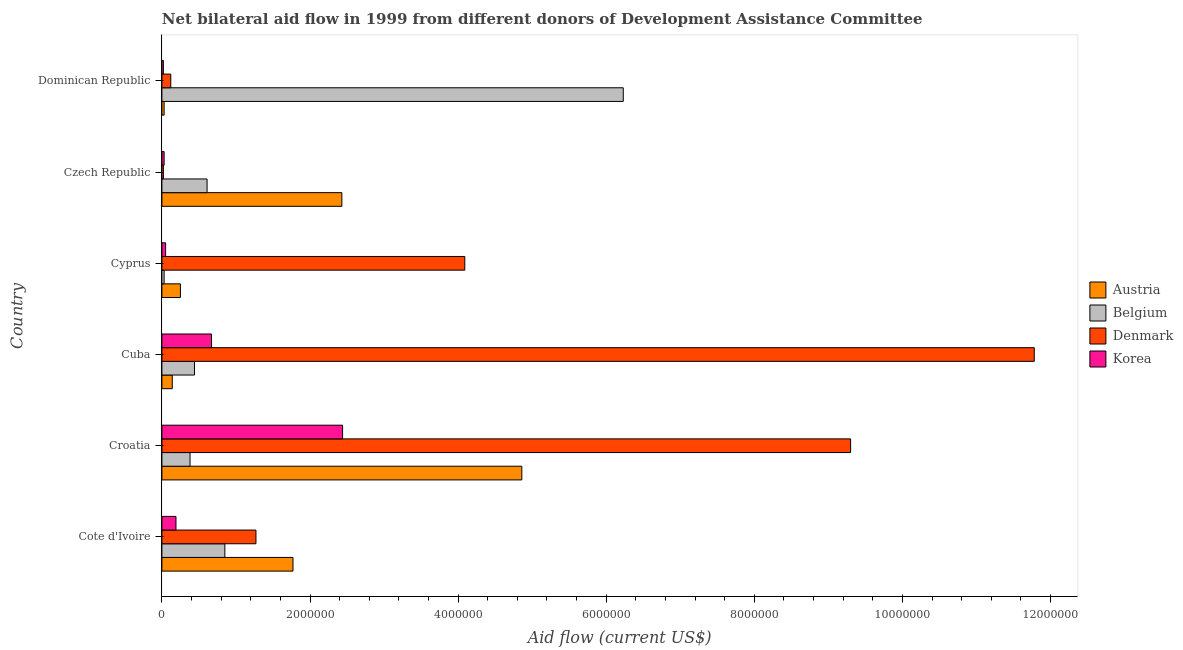Are the number of bars on each tick of the Y-axis equal?
Provide a succinct answer. Yes. How many bars are there on the 3rd tick from the bottom?
Your answer should be very brief. 4. What is the label of the 4th group of bars from the top?
Your answer should be compact. Cuba. What is the amount of aid given by korea in Dominican Republic?
Make the answer very short. 2.00e+04. Across all countries, what is the maximum amount of aid given by austria?
Provide a succinct answer. 4.86e+06. Across all countries, what is the minimum amount of aid given by korea?
Give a very brief answer. 2.00e+04. In which country was the amount of aid given by belgium maximum?
Keep it short and to the point. Dominican Republic. In which country was the amount of aid given by austria minimum?
Make the answer very short. Dominican Republic. What is the total amount of aid given by korea in the graph?
Your answer should be compact. 3.40e+06. What is the difference between the amount of aid given by austria in Cote d'Ivoire and that in Dominican Republic?
Your answer should be very brief. 1.74e+06. What is the difference between the amount of aid given by austria in Czech Republic and the amount of aid given by belgium in Cote d'Ivoire?
Ensure brevity in your answer.  1.58e+06. What is the average amount of aid given by belgium per country?
Offer a terse response. 1.42e+06. What is the difference between the amount of aid given by belgium and amount of aid given by austria in Czech Republic?
Keep it short and to the point. -1.82e+06. In how many countries, is the amount of aid given by denmark greater than 10800000 US$?
Offer a terse response. 1. What is the ratio of the amount of aid given by korea in Cyprus to that in Dominican Republic?
Provide a succinct answer. 2.5. Is the difference between the amount of aid given by korea in Cote d'Ivoire and Dominican Republic greater than the difference between the amount of aid given by belgium in Cote d'Ivoire and Dominican Republic?
Your answer should be compact. Yes. What is the difference between the highest and the second highest amount of aid given by korea?
Your response must be concise. 1.77e+06. What is the difference between the highest and the lowest amount of aid given by denmark?
Offer a terse response. 1.18e+07. Is the sum of the amount of aid given by korea in Czech Republic and Dominican Republic greater than the maximum amount of aid given by austria across all countries?
Make the answer very short. No. What does the 1st bar from the top in Croatia represents?
Your answer should be very brief. Korea. How many countries are there in the graph?
Your answer should be very brief. 6. What is the difference between two consecutive major ticks on the X-axis?
Give a very brief answer. 2.00e+06. Does the graph contain any zero values?
Keep it short and to the point. No. Does the graph contain grids?
Your response must be concise. No. What is the title of the graph?
Offer a terse response. Net bilateral aid flow in 1999 from different donors of Development Assistance Committee. Does "Taxes on income" appear as one of the legend labels in the graph?
Offer a terse response. No. What is the label or title of the X-axis?
Make the answer very short. Aid flow (current US$). What is the label or title of the Y-axis?
Your answer should be very brief. Country. What is the Aid flow (current US$) of Austria in Cote d'Ivoire?
Offer a very short reply. 1.77e+06. What is the Aid flow (current US$) of Belgium in Cote d'Ivoire?
Offer a very short reply. 8.50e+05. What is the Aid flow (current US$) of Denmark in Cote d'Ivoire?
Offer a terse response. 1.27e+06. What is the Aid flow (current US$) of Austria in Croatia?
Make the answer very short. 4.86e+06. What is the Aid flow (current US$) in Denmark in Croatia?
Provide a short and direct response. 9.30e+06. What is the Aid flow (current US$) of Korea in Croatia?
Your response must be concise. 2.44e+06. What is the Aid flow (current US$) of Austria in Cuba?
Offer a terse response. 1.40e+05. What is the Aid flow (current US$) in Denmark in Cuba?
Your answer should be compact. 1.18e+07. What is the Aid flow (current US$) in Korea in Cuba?
Provide a succinct answer. 6.70e+05. What is the Aid flow (current US$) in Belgium in Cyprus?
Your response must be concise. 3.00e+04. What is the Aid flow (current US$) in Denmark in Cyprus?
Your answer should be compact. 4.09e+06. What is the Aid flow (current US$) of Austria in Czech Republic?
Your answer should be compact. 2.43e+06. What is the Aid flow (current US$) in Belgium in Czech Republic?
Make the answer very short. 6.10e+05. What is the Aid flow (current US$) in Belgium in Dominican Republic?
Offer a terse response. 6.23e+06. Across all countries, what is the maximum Aid flow (current US$) in Austria?
Give a very brief answer. 4.86e+06. Across all countries, what is the maximum Aid flow (current US$) of Belgium?
Ensure brevity in your answer.  6.23e+06. Across all countries, what is the maximum Aid flow (current US$) of Denmark?
Make the answer very short. 1.18e+07. Across all countries, what is the maximum Aid flow (current US$) of Korea?
Your response must be concise. 2.44e+06. Across all countries, what is the minimum Aid flow (current US$) of Belgium?
Offer a terse response. 3.00e+04. What is the total Aid flow (current US$) in Austria in the graph?
Keep it short and to the point. 9.48e+06. What is the total Aid flow (current US$) in Belgium in the graph?
Keep it short and to the point. 8.54e+06. What is the total Aid flow (current US$) of Denmark in the graph?
Make the answer very short. 2.66e+07. What is the total Aid flow (current US$) of Korea in the graph?
Offer a terse response. 3.40e+06. What is the difference between the Aid flow (current US$) in Austria in Cote d'Ivoire and that in Croatia?
Ensure brevity in your answer.  -3.09e+06. What is the difference between the Aid flow (current US$) in Denmark in Cote d'Ivoire and that in Croatia?
Provide a short and direct response. -8.03e+06. What is the difference between the Aid flow (current US$) in Korea in Cote d'Ivoire and that in Croatia?
Make the answer very short. -2.25e+06. What is the difference between the Aid flow (current US$) in Austria in Cote d'Ivoire and that in Cuba?
Provide a succinct answer. 1.63e+06. What is the difference between the Aid flow (current US$) in Belgium in Cote d'Ivoire and that in Cuba?
Offer a terse response. 4.10e+05. What is the difference between the Aid flow (current US$) of Denmark in Cote d'Ivoire and that in Cuba?
Provide a short and direct response. -1.05e+07. What is the difference between the Aid flow (current US$) in Korea in Cote d'Ivoire and that in Cuba?
Make the answer very short. -4.80e+05. What is the difference between the Aid flow (current US$) of Austria in Cote d'Ivoire and that in Cyprus?
Ensure brevity in your answer.  1.52e+06. What is the difference between the Aid flow (current US$) in Belgium in Cote d'Ivoire and that in Cyprus?
Provide a short and direct response. 8.20e+05. What is the difference between the Aid flow (current US$) of Denmark in Cote d'Ivoire and that in Cyprus?
Give a very brief answer. -2.82e+06. What is the difference between the Aid flow (current US$) in Korea in Cote d'Ivoire and that in Cyprus?
Your answer should be very brief. 1.40e+05. What is the difference between the Aid flow (current US$) in Austria in Cote d'Ivoire and that in Czech Republic?
Keep it short and to the point. -6.60e+05. What is the difference between the Aid flow (current US$) of Belgium in Cote d'Ivoire and that in Czech Republic?
Keep it short and to the point. 2.40e+05. What is the difference between the Aid flow (current US$) in Denmark in Cote d'Ivoire and that in Czech Republic?
Ensure brevity in your answer.  1.25e+06. What is the difference between the Aid flow (current US$) in Korea in Cote d'Ivoire and that in Czech Republic?
Your response must be concise. 1.60e+05. What is the difference between the Aid flow (current US$) of Austria in Cote d'Ivoire and that in Dominican Republic?
Ensure brevity in your answer.  1.74e+06. What is the difference between the Aid flow (current US$) of Belgium in Cote d'Ivoire and that in Dominican Republic?
Offer a very short reply. -5.38e+06. What is the difference between the Aid flow (current US$) in Denmark in Cote d'Ivoire and that in Dominican Republic?
Your response must be concise. 1.15e+06. What is the difference between the Aid flow (current US$) of Austria in Croatia and that in Cuba?
Give a very brief answer. 4.72e+06. What is the difference between the Aid flow (current US$) in Denmark in Croatia and that in Cuba?
Offer a terse response. -2.48e+06. What is the difference between the Aid flow (current US$) of Korea in Croatia and that in Cuba?
Provide a succinct answer. 1.77e+06. What is the difference between the Aid flow (current US$) of Austria in Croatia and that in Cyprus?
Provide a short and direct response. 4.61e+06. What is the difference between the Aid flow (current US$) of Denmark in Croatia and that in Cyprus?
Provide a short and direct response. 5.21e+06. What is the difference between the Aid flow (current US$) of Korea in Croatia and that in Cyprus?
Your answer should be compact. 2.39e+06. What is the difference between the Aid flow (current US$) in Austria in Croatia and that in Czech Republic?
Give a very brief answer. 2.43e+06. What is the difference between the Aid flow (current US$) in Belgium in Croatia and that in Czech Republic?
Offer a very short reply. -2.30e+05. What is the difference between the Aid flow (current US$) of Denmark in Croatia and that in Czech Republic?
Provide a short and direct response. 9.28e+06. What is the difference between the Aid flow (current US$) of Korea in Croatia and that in Czech Republic?
Ensure brevity in your answer.  2.41e+06. What is the difference between the Aid flow (current US$) of Austria in Croatia and that in Dominican Republic?
Provide a short and direct response. 4.83e+06. What is the difference between the Aid flow (current US$) of Belgium in Croatia and that in Dominican Republic?
Offer a very short reply. -5.85e+06. What is the difference between the Aid flow (current US$) in Denmark in Croatia and that in Dominican Republic?
Offer a very short reply. 9.18e+06. What is the difference between the Aid flow (current US$) in Korea in Croatia and that in Dominican Republic?
Offer a very short reply. 2.42e+06. What is the difference between the Aid flow (current US$) of Denmark in Cuba and that in Cyprus?
Offer a terse response. 7.69e+06. What is the difference between the Aid flow (current US$) in Korea in Cuba and that in Cyprus?
Ensure brevity in your answer.  6.20e+05. What is the difference between the Aid flow (current US$) of Austria in Cuba and that in Czech Republic?
Your response must be concise. -2.29e+06. What is the difference between the Aid flow (current US$) in Belgium in Cuba and that in Czech Republic?
Offer a terse response. -1.70e+05. What is the difference between the Aid flow (current US$) of Denmark in Cuba and that in Czech Republic?
Provide a succinct answer. 1.18e+07. What is the difference between the Aid flow (current US$) of Korea in Cuba and that in Czech Republic?
Your answer should be compact. 6.40e+05. What is the difference between the Aid flow (current US$) of Austria in Cuba and that in Dominican Republic?
Offer a very short reply. 1.10e+05. What is the difference between the Aid flow (current US$) of Belgium in Cuba and that in Dominican Republic?
Offer a terse response. -5.79e+06. What is the difference between the Aid flow (current US$) of Denmark in Cuba and that in Dominican Republic?
Make the answer very short. 1.17e+07. What is the difference between the Aid flow (current US$) of Korea in Cuba and that in Dominican Republic?
Your answer should be compact. 6.50e+05. What is the difference between the Aid flow (current US$) of Austria in Cyprus and that in Czech Republic?
Provide a short and direct response. -2.18e+06. What is the difference between the Aid flow (current US$) of Belgium in Cyprus and that in Czech Republic?
Your answer should be compact. -5.80e+05. What is the difference between the Aid flow (current US$) of Denmark in Cyprus and that in Czech Republic?
Make the answer very short. 4.07e+06. What is the difference between the Aid flow (current US$) of Austria in Cyprus and that in Dominican Republic?
Provide a succinct answer. 2.20e+05. What is the difference between the Aid flow (current US$) of Belgium in Cyprus and that in Dominican Republic?
Give a very brief answer. -6.20e+06. What is the difference between the Aid flow (current US$) of Denmark in Cyprus and that in Dominican Republic?
Offer a terse response. 3.97e+06. What is the difference between the Aid flow (current US$) in Korea in Cyprus and that in Dominican Republic?
Give a very brief answer. 3.00e+04. What is the difference between the Aid flow (current US$) of Austria in Czech Republic and that in Dominican Republic?
Offer a very short reply. 2.40e+06. What is the difference between the Aid flow (current US$) in Belgium in Czech Republic and that in Dominican Republic?
Offer a terse response. -5.62e+06. What is the difference between the Aid flow (current US$) in Austria in Cote d'Ivoire and the Aid flow (current US$) in Belgium in Croatia?
Keep it short and to the point. 1.39e+06. What is the difference between the Aid flow (current US$) of Austria in Cote d'Ivoire and the Aid flow (current US$) of Denmark in Croatia?
Your answer should be very brief. -7.53e+06. What is the difference between the Aid flow (current US$) of Austria in Cote d'Ivoire and the Aid flow (current US$) of Korea in Croatia?
Make the answer very short. -6.70e+05. What is the difference between the Aid flow (current US$) of Belgium in Cote d'Ivoire and the Aid flow (current US$) of Denmark in Croatia?
Make the answer very short. -8.45e+06. What is the difference between the Aid flow (current US$) of Belgium in Cote d'Ivoire and the Aid flow (current US$) of Korea in Croatia?
Offer a very short reply. -1.59e+06. What is the difference between the Aid flow (current US$) in Denmark in Cote d'Ivoire and the Aid flow (current US$) in Korea in Croatia?
Offer a terse response. -1.17e+06. What is the difference between the Aid flow (current US$) of Austria in Cote d'Ivoire and the Aid flow (current US$) of Belgium in Cuba?
Provide a short and direct response. 1.33e+06. What is the difference between the Aid flow (current US$) in Austria in Cote d'Ivoire and the Aid flow (current US$) in Denmark in Cuba?
Give a very brief answer. -1.00e+07. What is the difference between the Aid flow (current US$) in Austria in Cote d'Ivoire and the Aid flow (current US$) in Korea in Cuba?
Ensure brevity in your answer.  1.10e+06. What is the difference between the Aid flow (current US$) of Belgium in Cote d'Ivoire and the Aid flow (current US$) of Denmark in Cuba?
Offer a terse response. -1.09e+07. What is the difference between the Aid flow (current US$) in Denmark in Cote d'Ivoire and the Aid flow (current US$) in Korea in Cuba?
Make the answer very short. 6.00e+05. What is the difference between the Aid flow (current US$) of Austria in Cote d'Ivoire and the Aid flow (current US$) of Belgium in Cyprus?
Your answer should be very brief. 1.74e+06. What is the difference between the Aid flow (current US$) of Austria in Cote d'Ivoire and the Aid flow (current US$) of Denmark in Cyprus?
Offer a terse response. -2.32e+06. What is the difference between the Aid flow (current US$) of Austria in Cote d'Ivoire and the Aid flow (current US$) of Korea in Cyprus?
Provide a succinct answer. 1.72e+06. What is the difference between the Aid flow (current US$) of Belgium in Cote d'Ivoire and the Aid flow (current US$) of Denmark in Cyprus?
Your answer should be very brief. -3.24e+06. What is the difference between the Aid flow (current US$) in Belgium in Cote d'Ivoire and the Aid flow (current US$) in Korea in Cyprus?
Your answer should be compact. 8.00e+05. What is the difference between the Aid flow (current US$) in Denmark in Cote d'Ivoire and the Aid flow (current US$) in Korea in Cyprus?
Your answer should be compact. 1.22e+06. What is the difference between the Aid flow (current US$) of Austria in Cote d'Ivoire and the Aid flow (current US$) of Belgium in Czech Republic?
Make the answer very short. 1.16e+06. What is the difference between the Aid flow (current US$) in Austria in Cote d'Ivoire and the Aid flow (current US$) in Denmark in Czech Republic?
Your response must be concise. 1.75e+06. What is the difference between the Aid flow (current US$) in Austria in Cote d'Ivoire and the Aid flow (current US$) in Korea in Czech Republic?
Keep it short and to the point. 1.74e+06. What is the difference between the Aid flow (current US$) of Belgium in Cote d'Ivoire and the Aid flow (current US$) of Denmark in Czech Republic?
Keep it short and to the point. 8.30e+05. What is the difference between the Aid flow (current US$) in Belgium in Cote d'Ivoire and the Aid flow (current US$) in Korea in Czech Republic?
Ensure brevity in your answer.  8.20e+05. What is the difference between the Aid flow (current US$) of Denmark in Cote d'Ivoire and the Aid flow (current US$) of Korea in Czech Republic?
Ensure brevity in your answer.  1.24e+06. What is the difference between the Aid flow (current US$) of Austria in Cote d'Ivoire and the Aid flow (current US$) of Belgium in Dominican Republic?
Your response must be concise. -4.46e+06. What is the difference between the Aid flow (current US$) in Austria in Cote d'Ivoire and the Aid flow (current US$) in Denmark in Dominican Republic?
Make the answer very short. 1.65e+06. What is the difference between the Aid flow (current US$) in Austria in Cote d'Ivoire and the Aid flow (current US$) in Korea in Dominican Republic?
Your answer should be very brief. 1.75e+06. What is the difference between the Aid flow (current US$) of Belgium in Cote d'Ivoire and the Aid flow (current US$) of Denmark in Dominican Republic?
Ensure brevity in your answer.  7.30e+05. What is the difference between the Aid flow (current US$) of Belgium in Cote d'Ivoire and the Aid flow (current US$) of Korea in Dominican Republic?
Provide a succinct answer. 8.30e+05. What is the difference between the Aid flow (current US$) in Denmark in Cote d'Ivoire and the Aid flow (current US$) in Korea in Dominican Republic?
Ensure brevity in your answer.  1.25e+06. What is the difference between the Aid flow (current US$) of Austria in Croatia and the Aid flow (current US$) of Belgium in Cuba?
Keep it short and to the point. 4.42e+06. What is the difference between the Aid flow (current US$) in Austria in Croatia and the Aid flow (current US$) in Denmark in Cuba?
Your answer should be very brief. -6.92e+06. What is the difference between the Aid flow (current US$) in Austria in Croatia and the Aid flow (current US$) in Korea in Cuba?
Ensure brevity in your answer.  4.19e+06. What is the difference between the Aid flow (current US$) in Belgium in Croatia and the Aid flow (current US$) in Denmark in Cuba?
Keep it short and to the point. -1.14e+07. What is the difference between the Aid flow (current US$) of Denmark in Croatia and the Aid flow (current US$) of Korea in Cuba?
Give a very brief answer. 8.63e+06. What is the difference between the Aid flow (current US$) of Austria in Croatia and the Aid flow (current US$) of Belgium in Cyprus?
Provide a succinct answer. 4.83e+06. What is the difference between the Aid flow (current US$) in Austria in Croatia and the Aid flow (current US$) in Denmark in Cyprus?
Your response must be concise. 7.70e+05. What is the difference between the Aid flow (current US$) in Austria in Croatia and the Aid flow (current US$) in Korea in Cyprus?
Ensure brevity in your answer.  4.81e+06. What is the difference between the Aid flow (current US$) in Belgium in Croatia and the Aid flow (current US$) in Denmark in Cyprus?
Your response must be concise. -3.71e+06. What is the difference between the Aid flow (current US$) in Denmark in Croatia and the Aid flow (current US$) in Korea in Cyprus?
Offer a very short reply. 9.25e+06. What is the difference between the Aid flow (current US$) of Austria in Croatia and the Aid flow (current US$) of Belgium in Czech Republic?
Keep it short and to the point. 4.25e+06. What is the difference between the Aid flow (current US$) in Austria in Croatia and the Aid flow (current US$) in Denmark in Czech Republic?
Make the answer very short. 4.84e+06. What is the difference between the Aid flow (current US$) in Austria in Croatia and the Aid flow (current US$) in Korea in Czech Republic?
Give a very brief answer. 4.83e+06. What is the difference between the Aid flow (current US$) of Belgium in Croatia and the Aid flow (current US$) of Denmark in Czech Republic?
Your answer should be very brief. 3.60e+05. What is the difference between the Aid flow (current US$) in Belgium in Croatia and the Aid flow (current US$) in Korea in Czech Republic?
Keep it short and to the point. 3.50e+05. What is the difference between the Aid flow (current US$) of Denmark in Croatia and the Aid flow (current US$) of Korea in Czech Republic?
Give a very brief answer. 9.27e+06. What is the difference between the Aid flow (current US$) in Austria in Croatia and the Aid flow (current US$) in Belgium in Dominican Republic?
Give a very brief answer. -1.37e+06. What is the difference between the Aid flow (current US$) of Austria in Croatia and the Aid flow (current US$) of Denmark in Dominican Republic?
Provide a short and direct response. 4.74e+06. What is the difference between the Aid flow (current US$) in Austria in Croatia and the Aid flow (current US$) in Korea in Dominican Republic?
Your answer should be very brief. 4.84e+06. What is the difference between the Aid flow (current US$) of Denmark in Croatia and the Aid flow (current US$) of Korea in Dominican Republic?
Keep it short and to the point. 9.28e+06. What is the difference between the Aid flow (current US$) in Austria in Cuba and the Aid flow (current US$) in Denmark in Cyprus?
Provide a succinct answer. -3.95e+06. What is the difference between the Aid flow (current US$) of Belgium in Cuba and the Aid flow (current US$) of Denmark in Cyprus?
Make the answer very short. -3.65e+06. What is the difference between the Aid flow (current US$) in Belgium in Cuba and the Aid flow (current US$) in Korea in Cyprus?
Give a very brief answer. 3.90e+05. What is the difference between the Aid flow (current US$) of Denmark in Cuba and the Aid flow (current US$) of Korea in Cyprus?
Your answer should be compact. 1.17e+07. What is the difference between the Aid flow (current US$) of Austria in Cuba and the Aid flow (current US$) of Belgium in Czech Republic?
Ensure brevity in your answer.  -4.70e+05. What is the difference between the Aid flow (current US$) in Austria in Cuba and the Aid flow (current US$) in Denmark in Czech Republic?
Your answer should be compact. 1.20e+05. What is the difference between the Aid flow (current US$) of Belgium in Cuba and the Aid flow (current US$) of Denmark in Czech Republic?
Make the answer very short. 4.20e+05. What is the difference between the Aid flow (current US$) in Belgium in Cuba and the Aid flow (current US$) in Korea in Czech Republic?
Give a very brief answer. 4.10e+05. What is the difference between the Aid flow (current US$) in Denmark in Cuba and the Aid flow (current US$) in Korea in Czech Republic?
Provide a succinct answer. 1.18e+07. What is the difference between the Aid flow (current US$) in Austria in Cuba and the Aid flow (current US$) in Belgium in Dominican Republic?
Provide a succinct answer. -6.09e+06. What is the difference between the Aid flow (current US$) of Austria in Cuba and the Aid flow (current US$) of Denmark in Dominican Republic?
Give a very brief answer. 2.00e+04. What is the difference between the Aid flow (current US$) in Austria in Cuba and the Aid flow (current US$) in Korea in Dominican Republic?
Make the answer very short. 1.20e+05. What is the difference between the Aid flow (current US$) in Belgium in Cuba and the Aid flow (current US$) in Denmark in Dominican Republic?
Provide a short and direct response. 3.20e+05. What is the difference between the Aid flow (current US$) of Denmark in Cuba and the Aid flow (current US$) of Korea in Dominican Republic?
Provide a succinct answer. 1.18e+07. What is the difference between the Aid flow (current US$) of Austria in Cyprus and the Aid flow (current US$) of Belgium in Czech Republic?
Offer a very short reply. -3.60e+05. What is the difference between the Aid flow (current US$) of Austria in Cyprus and the Aid flow (current US$) of Denmark in Czech Republic?
Offer a terse response. 2.30e+05. What is the difference between the Aid flow (current US$) of Austria in Cyprus and the Aid flow (current US$) of Korea in Czech Republic?
Ensure brevity in your answer.  2.20e+05. What is the difference between the Aid flow (current US$) in Belgium in Cyprus and the Aid flow (current US$) in Denmark in Czech Republic?
Keep it short and to the point. 10000. What is the difference between the Aid flow (current US$) in Belgium in Cyprus and the Aid flow (current US$) in Korea in Czech Republic?
Your response must be concise. 0. What is the difference between the Aid flow (current US$) of Denmark in Cyprus and the Aid flow (current US$) of Korea in Czech Republic?
Your response must be concise. 4.06e+06. What is the difference between the Aid flow (current US$) of Austria in Cyprus and the Aid flow (current US$) of Belgium in Dominican Republic?
Make the answer very short. -5.98e+06. What is the difference between the Aid flow (current US$) of Austria in Cyprus and the Aid flow (current US$) of Denmark in Dominican Republic?
Make the answer very short. 1.30e+05. What is the difference between the Aid flow (current US$) of Austria in Cyprus and the Aid flow (current US$) of Korea in Dominican Republic?
Give a very brief answer. 2.30e+05. What is the difference between the Aid flow (current US$) in Denmark in Cyprus and the Aid flow (current US$) in Korea in Dominican Republic?
Your answer should be compact. 4.07e+06. What is the difference between the Aid flow (current US$) of Austria in Czech Republic and the Aid flow (current US$) of Belgium in Dominican Republic?
Offer a terse response. -3.80e+06. What is the difference between the Aid flow (current US$) in Austria in Czech Republic and the Aid flow (current US$) in Denmark in Dominican Republic?
Offer a terse response. 2.31e+06. What is the difference between the Aid flow (current US$) of Austria in Czech Republic and the Aid flow (current US$) of Korea in Dominican Republic?
Provide a succinct answer. 2.41e+06. What is the difference between the Aid flow (current US$) in Belgium in Czech Republic and the Aid flow (current US$) in Korea in Dominican Republic?
Keep it short and to the point. 5.90e+05. What is the difference between the Aid flow (current US$) in Denmark in Czech Republic and the Aid flow (current US$) in Korea in Dominican Republic?
Keep it short and to the point. 0. What is the average Aid flow (current US$) in Austria per country?
Keep it short and to the point. 1.58e+06. What is the average Aid flow (current US$) in Belgium per country?
Provide a succinct answer. 1.42e+06. What is the average Aid flow (current US$) in Denmark per country?
Ensure brevity in your answer.  4.43e+06. What is the average Aid flow (current US$) of Korea per country?
Provide a succinct answer. 5.67e+05. What is the difference between the Aid flow (current US$) of Austria and Aid flow (current US$) of Belgium in Cote d'Ivoire?
Keep it short and to the point. 9.20e+05. What is the difference between the Aid flow (current US$) of Austria and Aid flow (current US$) of Denmark in Cote d'Ivoire?
Offer a very short reply. 5.00e+05. What is the difference between the Aid flow (current US$) of Austria and Aid flow (current US$) of Korea in Cote d'Ivoire?
Offer a very short reply. 1.58e+06. What is the difference between the Aid flow (current US$) in Belgium and Aid flow (current US$) in Denmark in Cote d'Ivoire?
Provide a short and direct response. -4.20e+05. What is the difference between the Aid flow (current US$) of Denmark and Aid flow (current US$) of Korea in Cote d'Ivoire?
Give a very brief answer. 1.08e+06. What is the difference between the Aid flow (current US$) in Austria and Aid flow (current US$) in Belgium in Croatia?
Provide a short and direct response. 4.48e+06. What is the difference between the Aid flow (current US$) in Austria and Aid flow (current US$) in Denmark in Croatia?
Offer a terse response. -4.44e+06. What is the difference between the Aid flow (current US$) of Austria and Aid flow (current US$) of Korea in Croatia?
Your response must be concise. 2.42e+06. What is the difference between the Aid flow (current US$) of Belgium and Aid flow (current US$) of Denmark in Croatia?
Your answer should be very brief. -8.92e+06. What is the difference between the Aid flow (current US$) in Belgium and Aid flow (current US$) in Korea in Croatia?
Keep it short and to the point. -2.06e+06. What is the difference between the Aid flow (current US$) in Denmark and Aid flow (current US$) in Korea in Croatia?
Give a very brief answer. 6.86e+06. What is the difference between the Aid flow (current US$) in Austria and Aid flow (current US$) in Denmark in Cuba?
Ensure brevity in your answer.  -1.16e+07. What is the difference between the Aid flow (current US$) in Austria and Aid flow (current US$) in Korea in Cuba?
Make the answer very short. -5.30e+05. What is the difference between the Aid flow (current US$) of Belgium and Aid flow (current US$) of Denmark in Cuba?
Keep it short and to the point. -1.13e+07. What is the difference between the Aid flow (current US$) of Denmark and Aid flow (current US$) of Korea in Cuba?
Provide a short and direct response. 1.11e+07. What is the difference between the Aid flow (current US$) of Austria and Aid flow (current US$) of Denmark in Cyprus?
Ensure brevity in your answer.  -3.84e+06. What is the difference between the Aid flow (current US$) of Belgium and Aid flow (current US$) of Denmark in Cyprus?
Ensure brevity in your answer.  -4.06e+06. What is the difference between the Aid flow (current US$) in Belgium and Aid flow (current US$) in Korea in Cyprus?
Provide a succinct answer. -2.00e+04. What is the difference between the Aid flow (current US$) of Denmark and Aid flow (current US$) of Korea in Cyprus?
Provide a short and direct response. 4.04e+06. What is the difference between the Aid flow (current US$) of Austria and Aid flow (current US$) of Belgium in Czech Republic?
Your answer should be compact. 1.82e+06. What is the difference between the Aid flow (current US$) of Austria and Aid flow (current US$) of Denmark in Czech Republic?
Provide a short and direct response. 2.41e+06. What is the difference between the Aid flow (current US$) of Austria and Aid flow (current US$) of Korea in Czech Republic?
Provide a succinct answer. 2.40e+06. What is the difference between the Aid flow (current US$) in Belgium and Aid flow (current US$) in Denmark in Czech Republic?
Offer a terse response. 5.90e+05. What is the difference between the Aid flow (current US$) of Belgium and Aid flow (current US$) of Korea in Czech Republic?
Offer a very short reply. 5.80e+05. What is the difference between the Aid flow (current US$) in Denmark and Aid flow (current US$) in Korea in Czech Republic?
Your answer should be compact. -10000. What is the difference between the Aid flow (current US$) in Austria and Aid flow (current US$) in Belgium in Dominican Republic?
Your answer should be compact. -6.20e+06. What is the difference between the Aid flow (current US$) in Austria and Aid flow (current US$) in Denmark in Dominican Republic?
Make the answer very short. -9.00e+04. What is the difference between the Aid flow (current US$) of Belgium and Aid flow (current US$) of Denmark in Dominican Republic?
Ensure brevity in your answer.  6.11e+06. What is the difference between the Aid flow (current US$) in Belgium and Aid flow (current US$) in Korea in Dominican Republic?
Make the answer very short. 6.21e+06. What is the ratio of the Aid flow (current US$) of Austria in Cote d'Ivoire to that in Croatia?
Offer a terse response. 0.36. What is the ratio of the Aid flow (current US$) in Belgium in Cote d'Ivoire to that in Croatia?
Keep it short and to the point. 2.24. What is the ratio of the Aid flow (current US$) in Denmark in Cote d'Ivoire to that in Croatia?
Your answer should be very brief. 0.14. What is the ratio of the Aid flow (current US$) in Korea in Cote d'Ivoire to that in Croatia?
Give a very brief answer. 0.08. What is the ratio of the Aid flow (current US$) of Austria in Cote d'Ivoire to that in Cuba?
Make the answer very short. 12.64. What is the ratio of the Aid flow (current US$) in Belgium in Cote d'Ivoire to that in Cuba?
Your answer should be very brief. 1.93. What is the ratio of the Aid flow (current US$) in Denmark in Cote d'Ivoire to that in Cuba?
Give a very brief answer. 0.11. What is the ratio of the Aid flow (current US$) of Korea in Cote d'Ivoire to that in Cuba?
Provide a short and direct response. 0.28. What is the ratio of the Aid flow (current US$) in Austria in Cote d'Ivoire to that in Cyprus?
Your response must be concise. 7.08. What is the ratio of the Aid flow (current US$) in Belgium in Cote d'Ivoire to that in Cyprus?
Provide a short and direct response. 28.33. What is the ratio of the Aid flow (current US$) in Denmark in Cote d'Ivoire to that in Cyprus?
Ensure brevity in your answer.  0.31. What is the ratio of the Aid flow (current US$) of Austria in Cote d'Ivoire to that in Czech Republic?
Provide a succinct answer. 0.73. What is the ratio of the Aid flow (current US$) of Belgium in Cote d'Ivoire to that in Czech Republic?
Offer a very short reply. 1.39. What is the ratio of the Aid flow (current US$) of Denmark in Cote d'Ivoire to that in Czech Republic?
Provide a short and direct response. 63.5. What is the ratio of the Aid flow (current US$) of Korea in Cote d'Ivoire to that in Czech Republic?
Offer a very short reply. 6.33. What is the ratio of the Aid flow (current US$) in Austria in Cote d'Ivoire to that in Dominican Republic?
Ensure brevity in your answer.  59. What is the ratio of the Aid flow (current US$) in Belgium in Cote d'Ivoire to that in Dominican Republic?
Your response must be concise. 0.14. What is the ratio of the Aid flow (current US$) in Denmark in Cote d'Ivoire to that in Dominican Republic?
Give a very brief answer. 10.58. What is the ratio of the Aid flow (current US$) in Korea in Cote d'Ivoire to that in Dominican Republic?
Keep it short and to the point. 9.5. What is the ratio of the Aid flow (current US$) in Austria in Croatia to that in Cuba?
Offer a very short reply. 34.71. What is the ratio of the Aid flow (current US$) in Belgium in Croatia to that in Cuba?
Provide a succinct answer. 0.86. What is the ratio of the Aid flow (current US$) in Denmark in Croatia to that in Cuba?
Your answer should be very brief. 0.79. What is the ratio of the Aid flow (current US$) of Korea in Croatia to that in Cuba?
Ensure brevity in your answer.  3.64. What is the ratio of the Aid flow (current US$) in Austria in Croatia to that in Cyprus?
Offer a terse response. 19.44. What is the ratio of the Aid flow (current US$) in Belgium in Croatia to that in Cyprus?
Make the answer very short. 12.67. What is the ratio of the Aid flow (current US$) of Denmark in Croatia to that in Cyprus?
Make the answer very short. 2.27. What is the ratio of the Aid flow (current US$) of Korea in Croatia to that in Cyprus?
Your answer should be compact. 48.8. What is the ratio of the Aid flow (current US$) in Belgium in Croatia to that in Czech Republic?
Keep it short and to the point. 0.62. What is the ratio of the Aid flow (current US$) of Denmark in Croatia to that in Czech Republic?
Offer a very short reply. 465. What is the ratio of the Aid flow (current US$) in Korea in Croatia to that in Czech Republic?
Provide a short and direct response. 81.33. What is the ratio of the Aid flow (current US$) of Austria in Croatia to that in Dominican Republic?
Make the answer very short. 162. What is the ratio of the Aid flow (current US$) in Belgium in Croatia to that in Dominican Republic?
Provide a succinct answer. 0.06. What is the ratio of the Aid flow (current US$) of Denmark in Croatia to that in Dominican Republic?
Offer a very short reply. 77.5. What is the ratio of the Aid flow (current US$) in Korea in Croatia to that in Dominican Republic?
Your answer should be compact. 122. What is the ratio of the Aid flow (current US$) in Austria in Cuba to that in Cyprus?
Offer a very short reply. 0.56. What is the ratio of the Aid flow (current US$) in Belgium in Cuba to that in Cyprus?
Give a very brief answer. 14.67. What is the ratio of the Aid flow (current US$) in Denmark in Cuba to that in Cyprus?
Give a very brief answer. 2.88. What is the ratio of the Aid flow (current US$) of Austria in Cuba to that in Czech Republic?
Provide a short and direct response. 0.06. What is the ratio of the Aid flow (current US$) in Belgium in Cuba to that in Czech Republic?
Offer a very short reply. 0.72. What is the ratio of the Aid flow (current US$) of Denmark in Cuba to that in Czech Republic?
Make the answer very short. 589. What is the ratio of the Aid flow (current US$) in Korea in Cuba to that in Czech Republic?
Provide a short and direct response. 22.33. What is the ratio of the Aid flow (current US$) of Austria in Cuba to that in Dominican Republic?
Keep it short and to the point. 4.67. What is the ratio of the Aid flow (current US$) in Belgium in Cuba to that in Dominican Republic?
Give a very brief answer. 0.07. What is the ratio of the Aid flow (current US$) of Denmark in Cuba to that in Dominican Republic?
Your answer should be compact. 98.17. What is the ratio of the Aid flow (current US$) of Korea in Cuba to that in Dominican Republic?
Provide a short and direct response. 33.5. What is the ratio of the Aid flow (current US$) of Austria in Cyprus to that in Czech Republic?
Ensure brevity in your answer.  0.1. What is the ratio of the Aid flow (current US$) of Belgium in Cyprus to that in Czech Republic?
Make the answer very short. 0.05. What is the ratio of the Aid flow (current US$) of Denmark in Cyprus to that in Czech Republic?
Keep it short and to the point. 204.5. What is the ratio of the Aid flow (current US$) in Korea in Cyprus to that in Czech Republic?
Offer a very short reply. 1.67. What is the ratio of the Aid flow (current US$) of Austria in Cyprus to that in Dominican Republic?
Your answer should be very brief. 8.33. What is the ratio of the Aid flow (current US$) in Belgium in Cyprus to that in Dominican Republic?
Provide a short and direct response. 0. What is the ratio of the Aid flow (current US$) in Denmark in Cyprus to that in Dominican Republic?
Your response must be concise. 34.08. What is the ratio of the Aid flow (current US$) in Austria in Czech Republic to that in Dominican Republic?
Your response must be concise. 81. What is the ratio of the Aid flow (current US$) in Belgium in Czech Republic to that in Dominican Republic?
Your answer should be very brief. 0.1. What is the ratio of the Aid flow (current US$) in Denmark in Czech Republic to that in Dominican Republic?
Make the answer very short. 0.17. What is the ratio of the Aid flow (current US$) of Korea in Czech Republic to that in Dominican Republic?
Your answer should be very brief. 1.5. What is the difference between the highest and the second highest Aid flow (current US$) in Austria?
Your answer should be very brief. 2.43e+06. What is the difference between the highest and the second highest Aid flow (current US$) of Belgium?
Your response must be concise. 5.38e+06. What is the difference between the highest and the second highest Aid flow (current US$) in Denmark?
Your answer should be very brief. 2.48e+06. What is the difference between the highest and the second highest Aid flow (current US$) in Korea?
Your answer should be very brief. 1.77e+06. What is the difference between the highest and the lowest Aid flow (current US$) in Austria?
Make the answer very short. 4.83e+06. What is the difference between the highest and the lowest Aid flow (current US$) in Belgium?
Your answer should be very brief. 6.20e+06. What is the difference between the highest and the lowest Aid flow (current US$) of Denmark?
Offer a very short reply. 1.18e+07. What is the difference between the highest and the lowest Aid flow (current US$) of Korea?
Your response must be concise. 2.42e+06. 